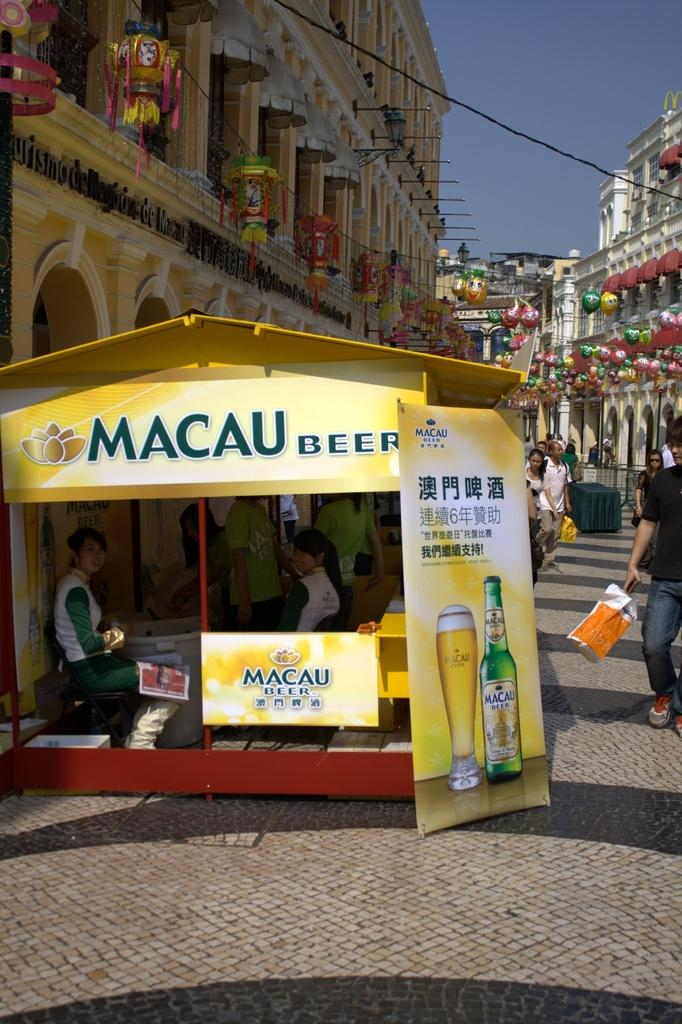<image>
Render a clear and concise summary of the photo. A Macau Beer booth is situated in a pedestrian shopping area. 